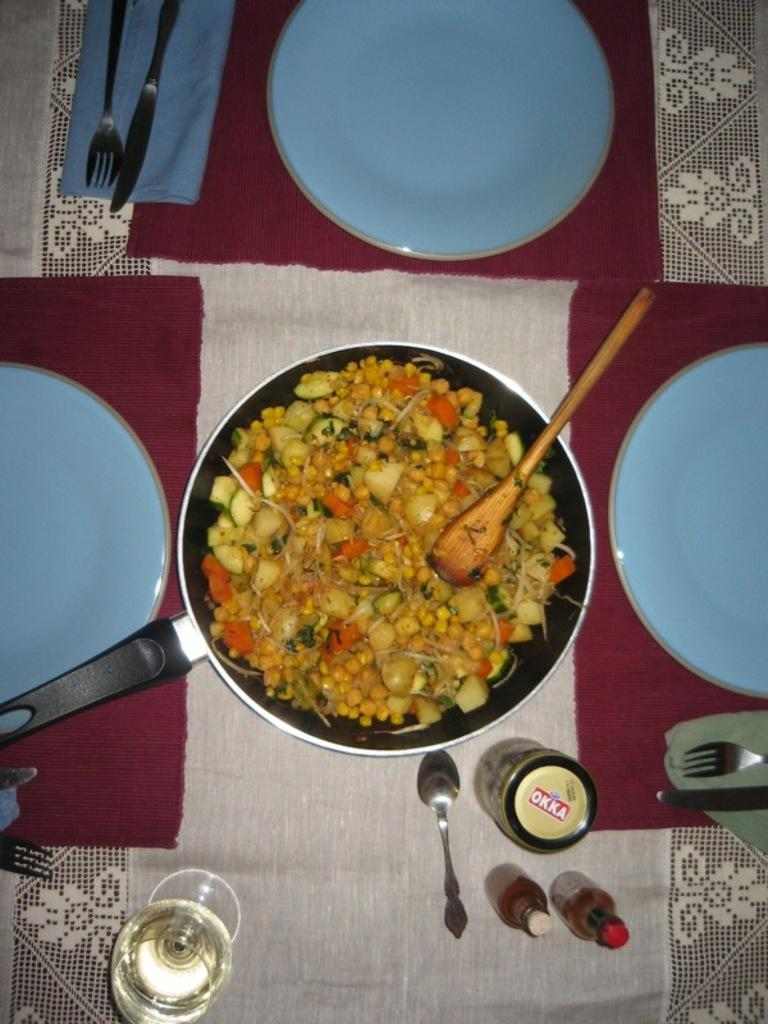What is the main piece of furniture in the image? There is a table in the image. What is covering the table? There is a cloth on the table. What objects are placed on the cloth? There are plates, spoons, forks, and a pan on the cloth. What is inside the pan? There is a food item in the pan. What type of plants can be seen growing on the table in the image? There are no plants visible on the table in the image. What time does the clock on the table indicate in the image? There is no clock present on the table in the image. 